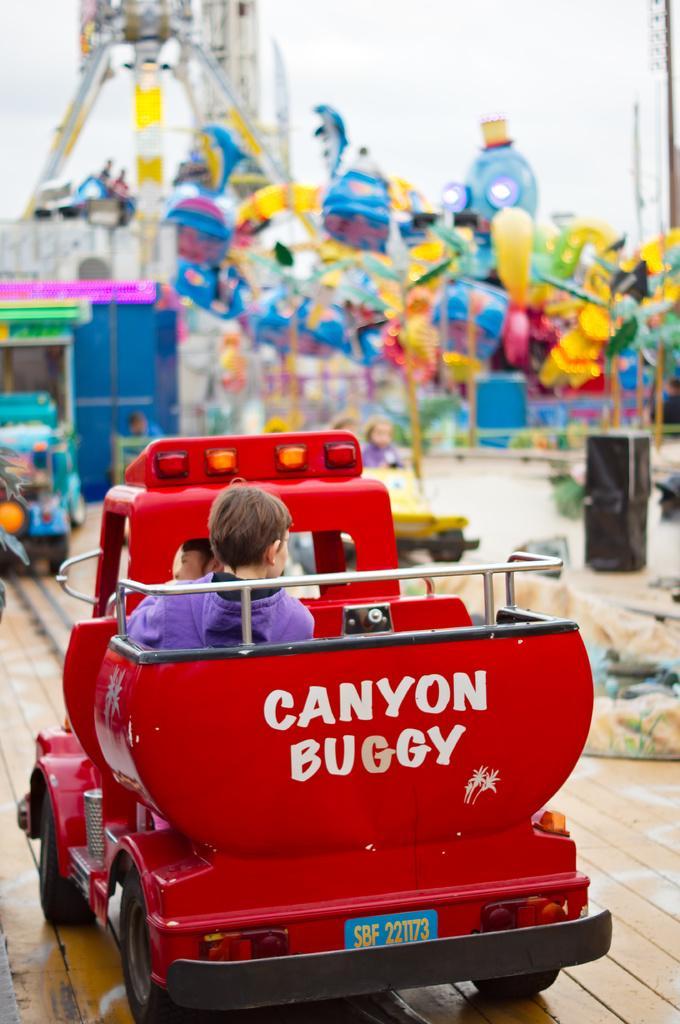How would you summarize this image in a sentence or two? In this image, in the middle, we can see a toy car, in the toy car, we can see two people are sitting. In the background, we can see some toys and some playing instruments. At the top, we can see a sky. 